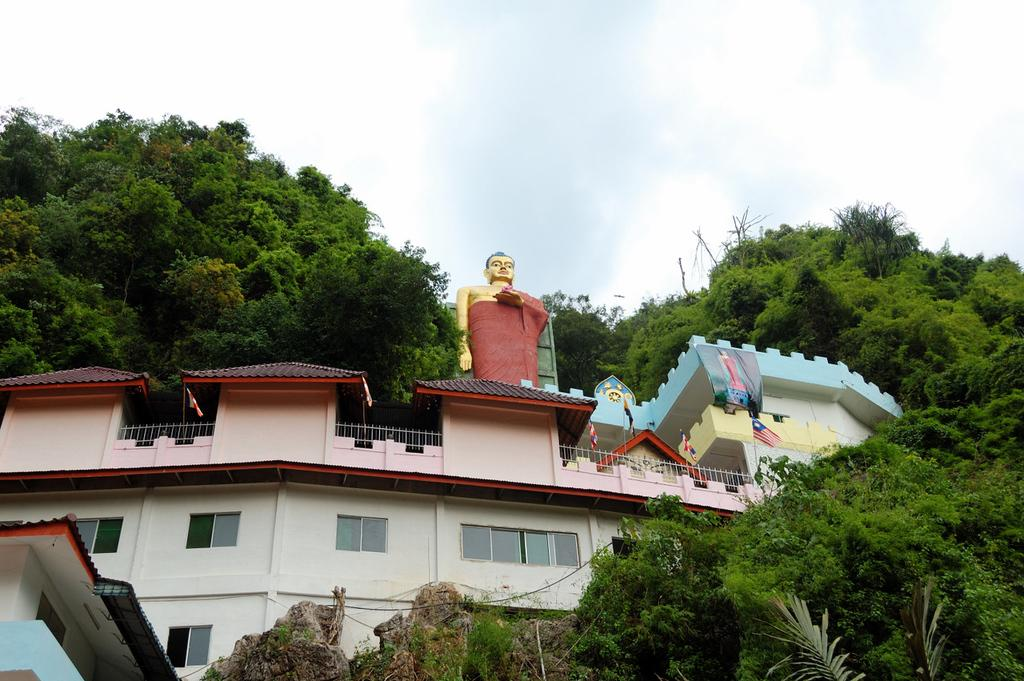What type of structure is visible in the image? There is a building in the image. What is on top of the building? There is a sculpture on top of the building. What type of vegetation can be seen in the image? There are trees in the image. How far away is the scarecrow from the building in the image? There is no scarecrow present in the image, so it cannot be determined how far away it might be from the building. 